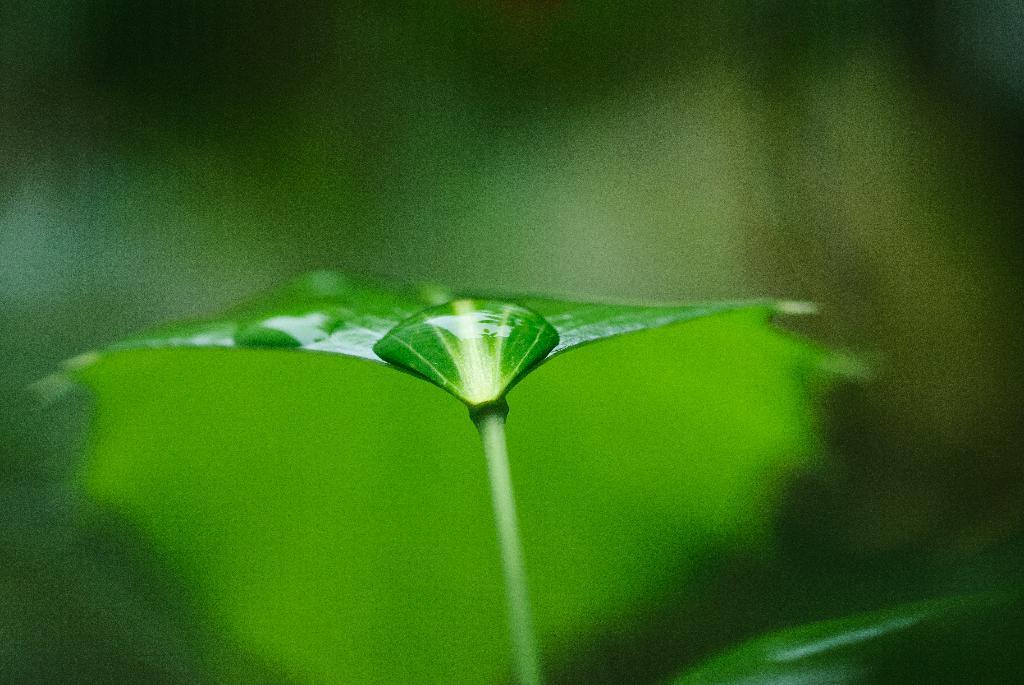In one or two sentences, can you explain what this image depicts? Here we can see green leaf with water drops. Background it is blur. 